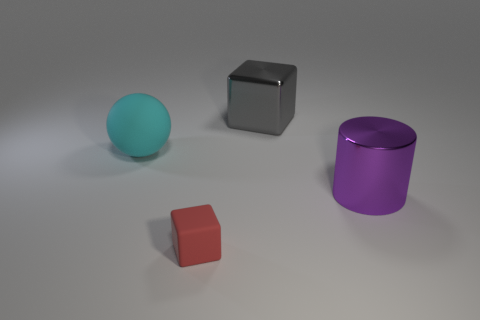Does the rubber block have the same color as the big rubber object?
Your answer should be very brief. No. What is the color of the object in front of the shiny thing on the right side of the big shiny block?
Your response must be concise. Red. How many big things are either rubber things or purple metallic things?
Your response must be concise. 2. What is the color of the thing that is in front of the metal block and behind the purple metallic thing?
Offer a terse response. Cyan. Does the tiny red thing have the same material as the cyan ball?
Make the answer very short. Yes. What is the shape of the big purple thing?
Keep it short and to the point. Cylinder. What number of purple metal objects are on the left side of the rubber object right of the big thing on the left side of the tiny object?
Your response must be concise. 0. What color is the other thing that is the same shape as the tiny thing?
Ensure brevity in your answer.  Gray. What shape is the large shiny thing right of the large metal thing on the left side of the object that is right of the big metallic cube?
Make the answer very short. Cylinder. How big is the object that is both in front of the big cyan object and behind the tiny object?
Your response must be concise. Large. 